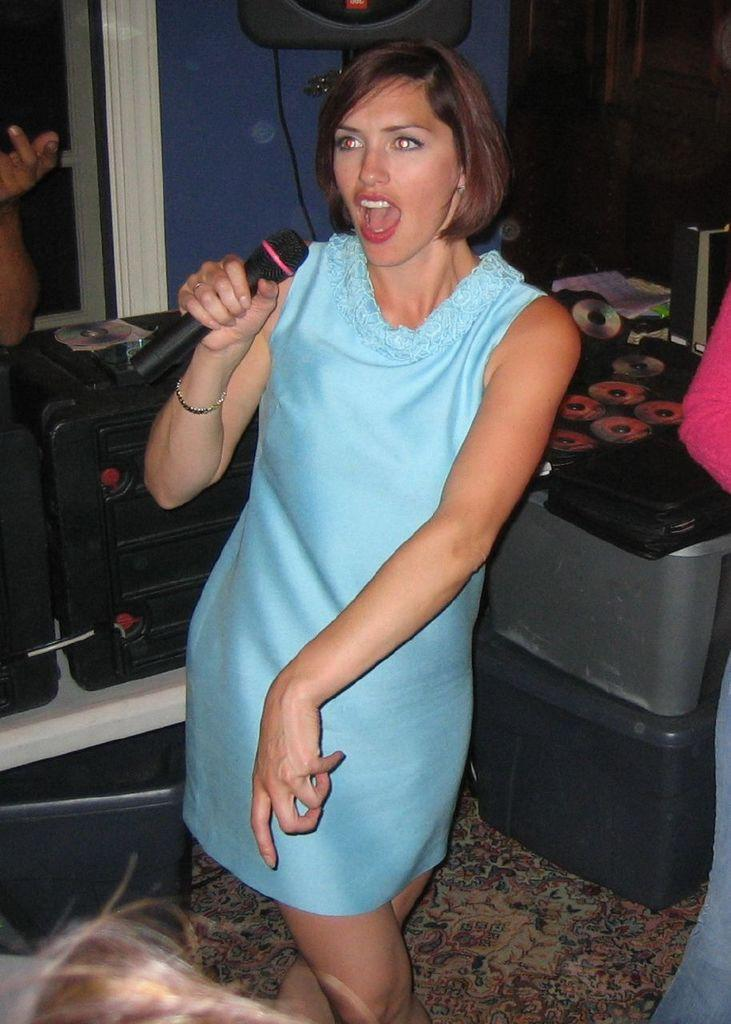Who is the main subject in the image? There is a woman in the image. What is the woman holding in the image? The woman is holding a microphone. What other objects can be seen in the image? There are musical instruments in the image. Can you tell me what type of soup the woman is holding in the image? There is no soup present in the image; the woman is holding a microphone. Is the woman's friend visible in the image? The provided facts do not mention a friend, so we cannot determine if a friend is present in the image. 